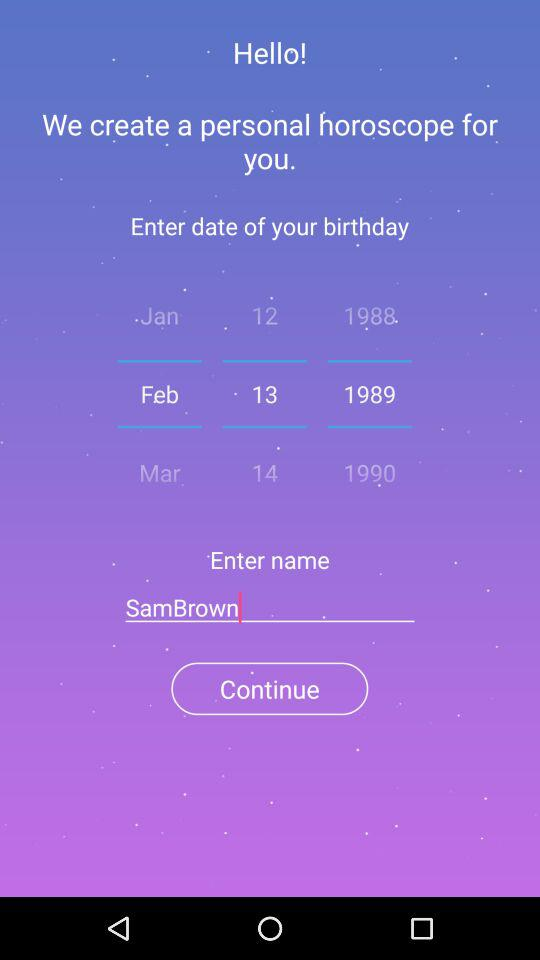What is the selected date? The selected date is February 13, 1989. 